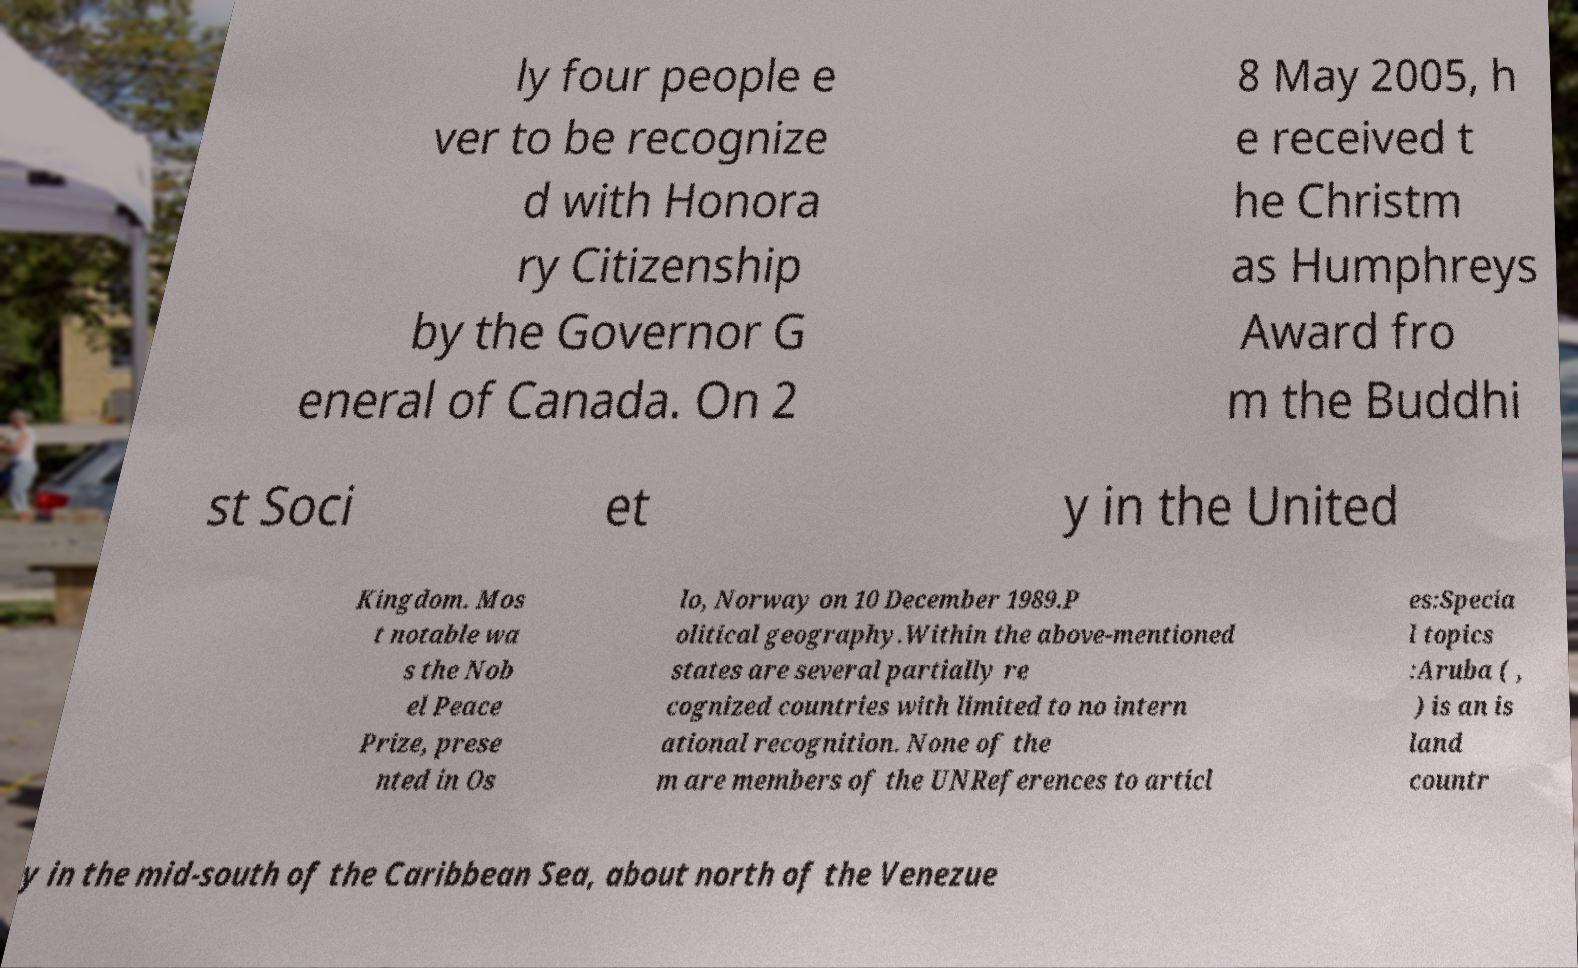What messages or text are displayed in this image? I need them in a readable, typed format. ly four people e ver to be recognize d with Honora ry Citizenship by the Governor G eneral of Canada. On 2 8 May 2005, h e received t he Christm as Humphreys Award fro m the Buddhi st Soci et y in the United Kingdom. Mos t notable wa s the Nob el Peace Prize, prese nted in Os lo, Norway on 10 December 1989.P olitical geography.Within the above-mentioned states are several partially re cognized countries with limited to no intern ational recognition. None of the m are members of the UNReferences to articl es:Specia l topics :Aruba ( , ) is an is land countr y in the mid-south of the Caribbean Sea, about north of the Venezue 